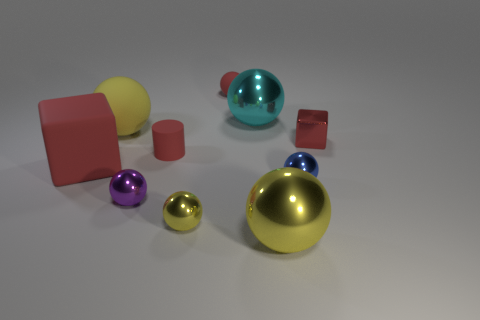How many yellow balls must be subtracted to get 1 yellow balls? 2 Subtract all gray cubes. How many yellow spheres are left? 3 Subtract all purple balls. How many balls are left? 6 Subtract all small red matte spheres. How many spheres are left? 6 Subtract all gray balls. Subtract all blue cylinders. How many balls are left? 7 Subtract all balls. How many objects are left? 3 Add 3 big yellow things. How many big yellow things exist? 5 Subtract 0 green cubes. How many objects are left? 10 Subtract all red metal spheres. Subtract all large cyan objects. How many objects are left? 9 Add 2 matte cylinders. How many matte cylinders are left? 3 